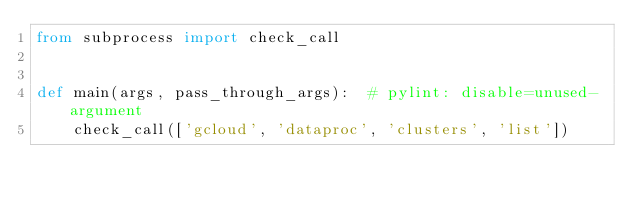<code> <loc_0><loc_0><loc_500><loc_500><_Python_>from subprocess import check_call


def main(args, pass_through_args):  # pylint: disable=unused-argument
    check_call(['gcloud', 'dataproc', 'clusters', 'list'])
</code> 